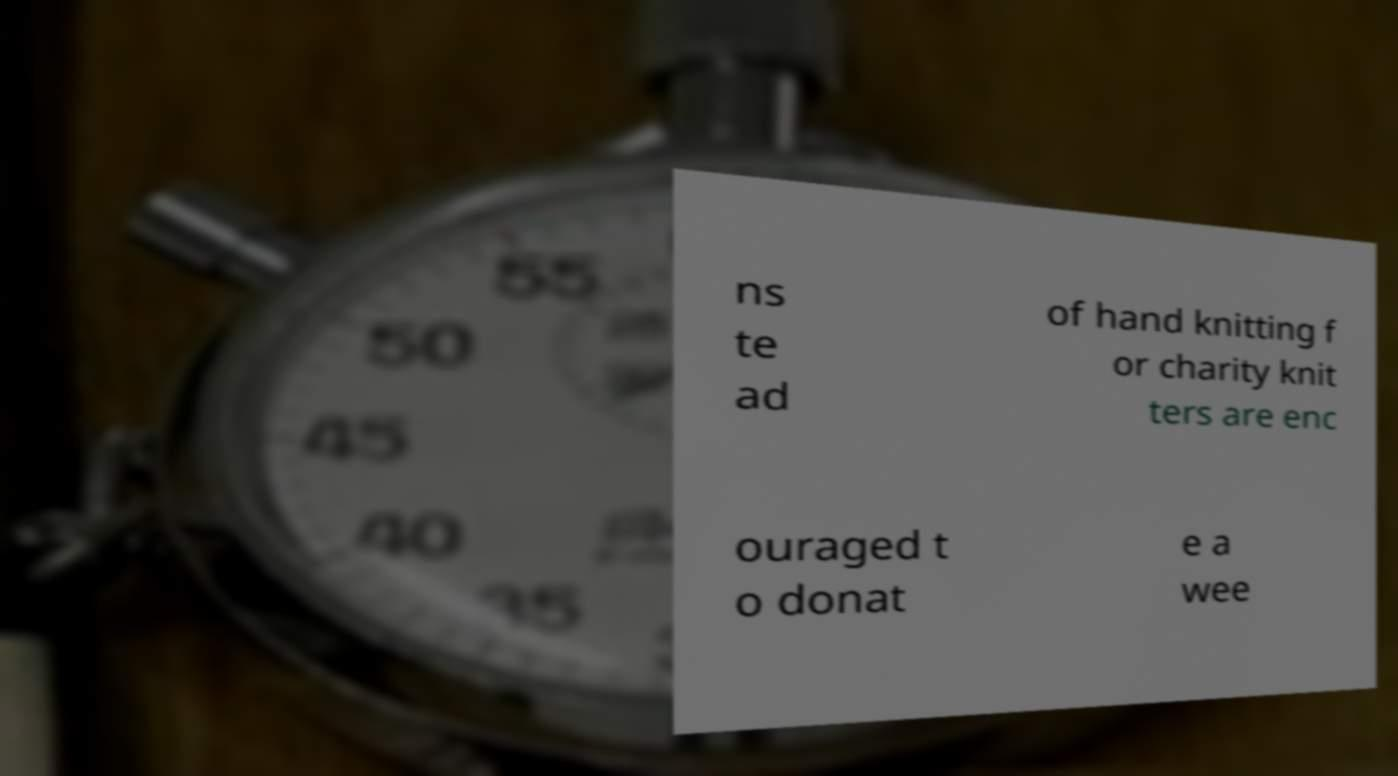Could you extract and type out the text from this image? ns te ad of hand knitting f or charity knit ters are enc ouraged t o donat e a wee 